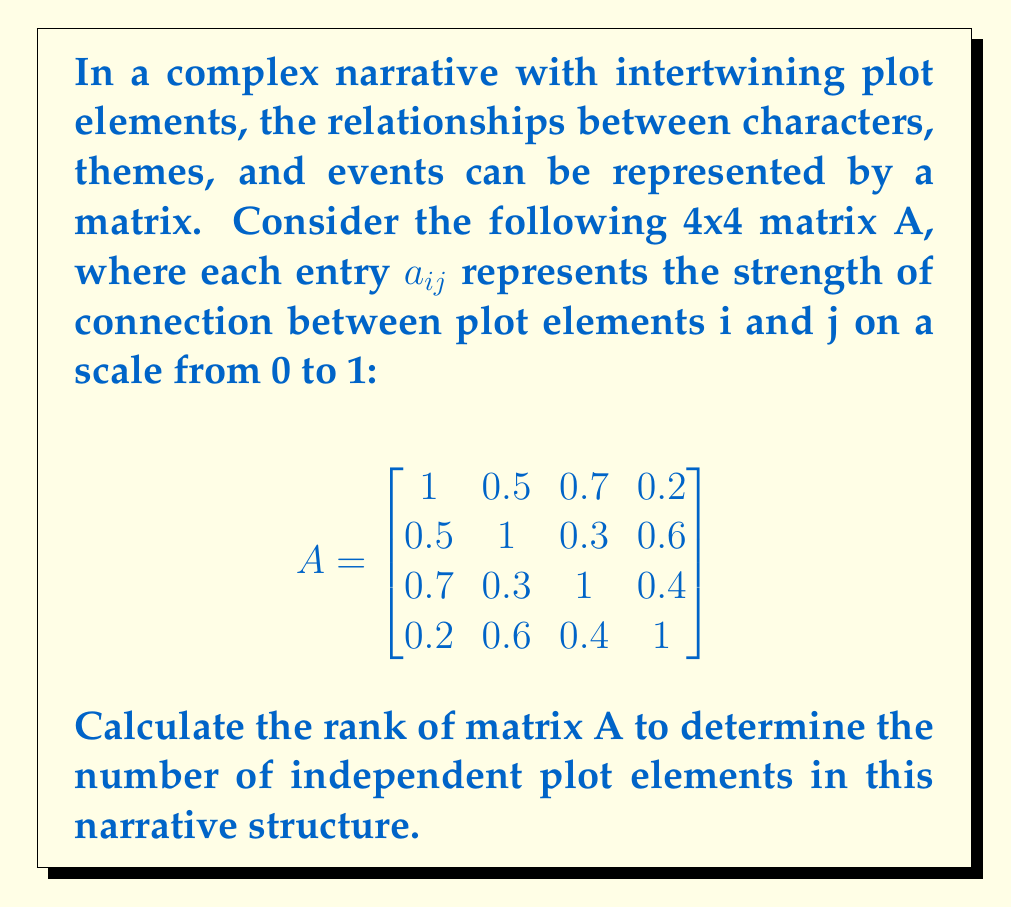Provide a solution to this math problem. To calculate the rank of matrix A, we need to determine the number of linearly independent rows or columns. We can do this by reducing the matrix to row echelon form and counting the number of non-zero rows.

Step 1: Write the augmented matrix [A | 0].

$$\begin{bmatrix}
1 & 0.5 & 0.7 & 0.2 & | & 0 \\
0.5 & 1 & 0.3 & 0.6 & | & 0 \\
0.7 & 0.3 & 1 & 0.4 & | & 0 \\
0.2 & 0.6 & 0.4 & 1 & | & 0
\end{bmatrix}$$

Step 2: Use Gaussian elimination to reduce the matrix to row echelon form.

R2 = R2 - 0.5R1:
$$\begin{bmatrix}
1 & 0.5 & 0.7 & 0.2 & | & 0 \\
0 & 0.75 & -0.05 & 0.5 & | & 0 \\
0.7 & 0.3 & 1 & 0.4 & | & 0 \\
0.2 & 0.6 & 0.4 & 1 & | & 0
\end{bmatrix}$$

R3 = R3 - 0.7R1:
$$\begin{bmatrix}
1 & 0.5 & 0.7 & 0.2 & | & 0 \\
0 & 0.75 & -0.05 & 0.5 & | & 0 \\
0 & -0.05 & 0.51 & 0.26 & | & 0 \\
0.2 & 0.6 & 0.4 & 1 & | & 0
\end{bmatrix}$$

R4 = R4 - 0.2R1:
$$\begin{bmatrix}
1 & 0.5 & 0.7 & 0.2 & | & 0 \\
0 & 0.75 & -0.05 & 0.5 & | & 0 \\
0 & -0.05 & 0.51 & 0.26 & | & 0 \\
0 & 0.5 & 0.26 & 0.96 & | & 0
\end{bmatrix}$$

R3 = R3 + (1/15)R2:
$$\begin{bmatrix}
1 & 0.5 & 0.7 & 0.2 & | & 0 \\
0 & 0.75 & -0.05 & 0.5 & | & 0 \\
0 & 0 & 0.5 & 0.2933 & | & 0 \\
0 & 0.5 & 0.26 & 0.96 & | & 0
\end{bmatrix}$$

R4 = R4 - (2/3)R2:
$$\begin{bmatrix}
1 & 0.5 & 0.7 & 0.2 & | & 0 \\
0 & 0.75 & -0.05 & 0.5 & | & 0 \\
0 & 0 & 0.5 & 0.2933 & | & 0 \\
0 & 0 & 0.2933 & 0.6267 & | & 0
\end{bmatrix}$$

R4 = R4 - 0.5867R3:
$$\begin{bmatrix}
1 & 0.5 & 0.7 & 0.2 & | & 0 \\
0 & 0.75 & -0.05 & 0.5 & | & 0 \\
0 & 0 & 0.5 & 0.2933 & | & 0 \\
0 & 0 & 0 & 0.4547 & | & 0
\end{bmatrix}$$

Step 3: Count the number of non-zero rows in the row echelon form.

The matrix has 4 non-zero rows, which means all rows are linearly independent.

Therefore, the rank of matrix A is 4.
Answer: 4 